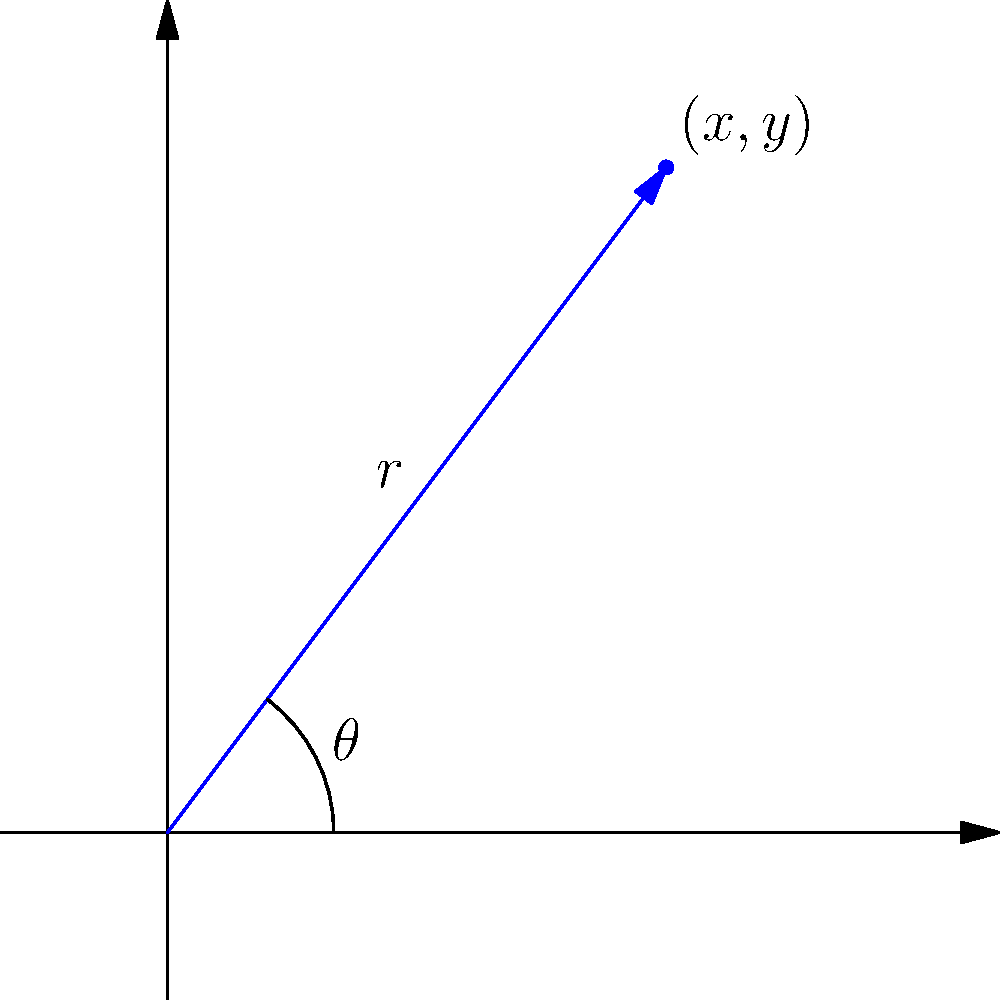Given a point with Cartesian coordinates $(3,4)$, quickly calculate its polar coordinates $(r,\theta)$ for data visualization. Round $r$ to the nearest integer and $\theta$ to the nearest degree. 1. Calculate $r$:
   $r = \sqrt{x^2 + y^2} = \sqrt{3^2 + 4^2} = \sqrt{9 + 16} = \sqrt{25} = 5$

2. Calculate $\theta$:
   $\theta = \arctan(\frac{y}{x}) = \arctan(\frac{4}{3})$
   
   Using a calculator or quick approximation:
   $\arctan(\frac{4}{3}) \approx 53.13^\circ$

3. Round $r$ to the nearest integer:
   $r \approx 5$

4. Round $\theta$ to the nearest degree:
   $\theta \approx 53^\circ$

Therefore, the polar coordinates are approximately $(5, 53^\circ)$.
Answer: $(5, 53^\circ)$ 